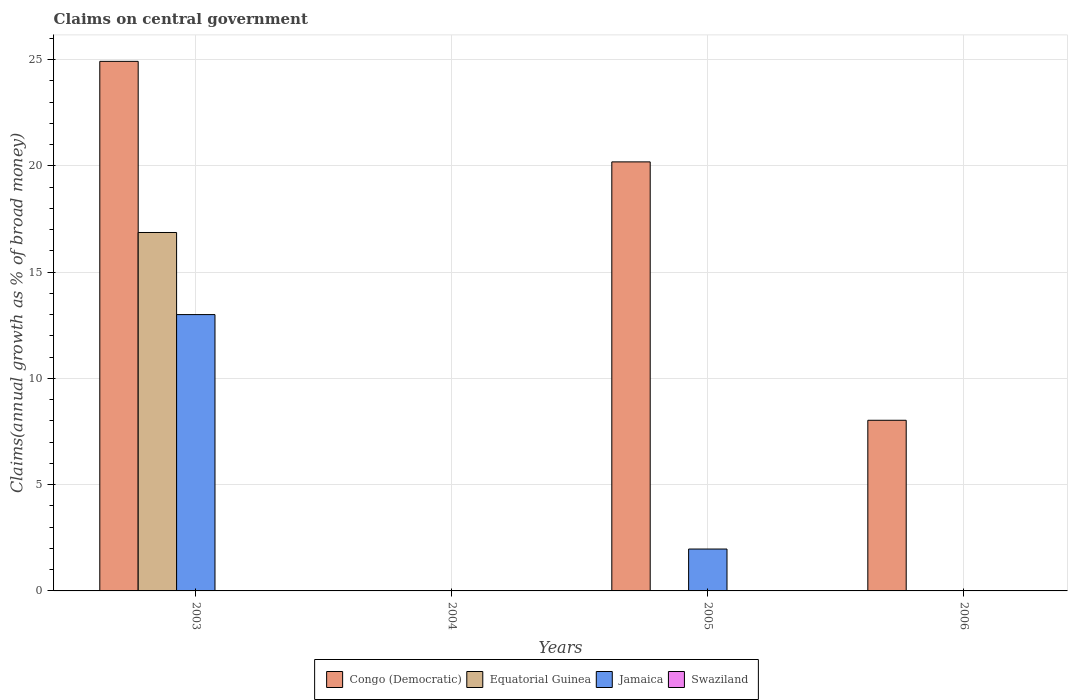Are the number of bars per tick equal to the number of legend labels?
Your answer should be very brief. No. Are the number of bars on each tick of the X-axis equal?
Your response must be concise. No. How many bars are there on the 2nd tick from the left?
Ensure brevity in your answer.  0. How many bars are there on the 3rd tick from the right?
Give a very brief answer. 0. What is the label of the 4th group of bars from the left?
Make the answer very short. 2006. Across all years, what is the maximum percentage of broad money claimed on centeral government in Equatorial Guinea?
Provide a succinct answer. 16.86. What is the total percentage of broad money claimed on centeral government in Swaziland in the graph?
Provide a succinct answer. 0. What is the difference between the percentage of broad money claimed on centeral government in Congo (Democratic) in 2003 and that in 2005?
Keep it short and to the point. 4.73. What is the difference between the percentage of broad money claimed on centeral government in Congo (Democratic) in 2005 and the percentage of broad money claimed on centeral government in Jamaica in 2006?
Your answer should be compact. 20.18. What is the average percentage of broad money claimed on centeral government in Congo (Democratic) per year?
Provide a succinct answer. 13.28. In the year 2005, what is the difference between the percentage of broad money claimed on centeral government in Congo (Democratic) and percentage of broad money claimed on centeral government in Jamaica?
Your answer should be compact. 18.21. In how many years, is the percentage of broad money claimed on centeral government in Swaziland greater than 18 %?
Give a very brief answer. 0. What is the difference between the highest and the second highest percentage of broad money claimed on centeral government in Congo (Democratic)?
Provide a short and direct response. 4.73. What is the difference between the highest and the lowest percentage of broad money claimed on centeral government in Jamaica?
Your response must be concise. 13. In how many years, is the percentage of broad money claimed on centeral government in Jamaica greater than the average percentage of broad money claimed on centeral government in Jamaica taken over all years?
Give a very brief answer. 1. Is it the case that in every year, the sum of the percentage of broad money claimed on centeral government in Swaziland and percentage of broad money claimed on centeral government in Congo (Democratic) is greater than the sum of percentage of broad money claimed on centeral government in Jamaica and percentage of broad money claimed on centeral government in Equatorial Guinea?
Offer a very short reply. No. How many bars are there?
Provide a short and direct response. 6. What is the difference between two consecutive major ticks on the Y-axis?
Your answer should be very brief. 5. Are the values on the major ticks of Y-axis written in scientific E-notation?
Your answer should be very brief. No. Does the graph contain any zero values?
Keep it short and to the point. Yes. Where does the legend appear in the graph?
Your answer should be very brief. Bottom center. How many legend labels are there?
Provide a short and direct response. 4. What is the title of the graph?
Give a very brief answer. Claims on central government. Does "South Sudan" appear as one of the legend labels in the graph?
Make the answer very short. No. What is the label or title of the X-axis?
Ensure brevity in your answer.  Years. What is the label or title of the Y-axis?
Offer a very short reply. Claims(annual growth as % of broad money). What is the Claims(annual growth as % of broad money) of Congo (Democratic) in 2003?
Provide a succinct answer. 24.91. What is the Claims(annual growth as % of broad money) in Equatorial Guinea in 2003?
Provide a short and direct response. 16.86. What is the Claims(annual growth as % of broad money) of Jamaica in 2003?
Make the answer very short. 13. What is the Claims(annual growth as % of broad money) in Swaziland in 2003?
Your answer should be compact. 0. What is the Claims(annual growth as % of broad money) in Congo (Democratic) in 2004?
Offer a terse response. 0. What is the Claims(annual growth as % of broad money) of Jamaica in 2004?
Keep it short and to the point. 0. What is the Claims(annual growth as % of broad money) in Congo (Democratic) in 2005?
Ensure brevity in your answer.  20.18. What is the Claims(annual growth as % of broad money) of Jamaica in 2005?
Your response must be concise. 1.97. What is the Claims(annual growth as % of broad money) of Swaziland in 2005?
Offer a very short reply. 0. What is the Claims(annual growth as % of broad money) in Congo (Democratic) in 2006?
Offer a very short reply. 8.03. Across all years, what is the maximum Claims(annual growth as % of broad money) of Congo (Democratic)?
Provide a succinct answer. 24.91. Across all years, what is the maximum Claims(annual growth as % of broad money) of Equatorial Guinea?
Offer a very short reply. 16.86. Across all years, what is the maximum Claims(annual growth as % of broad money) in Jamaica?
Your answer should be very brief. 13. Across all years, what is the minimum Claims(annual growth as % of broad money) of Equatorial Guinea?
Make the answer very short. 0. What is the total Claims(annual growth as % of broad money) of Congo (Democratic) in the graph?
Make the answer very short. 53.13. What is the total Claims(annual growth as % of broad money) of Equatorial Guinea in the graph?
Keep it short and to the point. 16.86. What is the total Claims(annual growth as % of broad money) of Jamaica in the graph?
Keep it short and to the point. 14.97. What is the total Claims(annual growth as % of broad money) of Swaziland in the graph?
Keep it short and to the point. 0. What is the difference between the Claims(annual growth as % of broad money) of Congo (Democratic) in 2003 and that in 2005?
Offer a terse response. 4.73. What is the difference between the Claims(annual growth as % of broad money) of Jamaica in 2003 and that in 2005?
Offer a terse response. 11.03. What is the difference between the Claims(annual growth as % of broad money) in Congo (Democratic) in 2003 and that in 2006?
Offer a terse response. 16.89. What is the difference between the Claims(annual growth as % of broad money) of Congo (Democratic) in 2005 and that in 2006?
Your answer should be very brief. 12.16. What is the difference between the Claims(annual growth as % of broad money) in Congo (Democratic) in 2003 and the Claims(annual growth as % of broad money) in Jamaica in 2005?
Your answer should be compact. 22.94. What is the difference between the Claims(annual growth as % of broad money) in Equatorial Guinea in 2003 and the Claims(annual growth as % of broad money) in Jamaica in 2005?
Provide a short and direct response. 14.89. What is the average Claims(annual growth as % of broad money) in Congo (Democratic) per year?
Make the answer very short. 13.28. What is the average Claims(annual growth as % of broad money) in Equatorial Guinea per year?
Offer a terse response. 4.22. What is the average Claims(annual growth as % of broad money) of Jamaica per year?
Provide a succinct answer. 3.74. In the year 2003, what is the difference between the Claims(annual growth as % of broad money) of Congo (Democratic) and Claims(annual growth as % of broad money) of Equatorial Guinea?
Make the answer very short. 8.05. In the year 2003, what is the difference between the Claims(annual growth as % of broad money) in Congo (Democratic) and Claims(annual growth as % of broad money) in Jamaica?
Provide a succinct answer. 11.91. In the year 2003, what is the difference between the Claims(annual growth as % of broad money) of Equatorial Guinea and Claims(annual growth as % of broad money) of Jamaica?
Your answer should be compact. 3.86. In the year 2005, what is the difference between the Claims(annual growth as % of broad money) of Congo (Democratic) and Claims(annual growth as % of broad money) of Jamaica?
Your response must be concise. 18.21. What is the ratio of the Claims(annual growth as % of broad money) of Congo (Democratic) in 2003 to that in 2005?
Your response must be concise. 1.23. What is the ratio of the Claims(annual growth as % of broad money) in Jamaica in 2003 to that in 2005?
Offer a terse response. 6.6. What is the ratio of the Claims(annual growth as % of broad money) of Congo (Democratic) in 2003 to that in 2006?
Your answer should be very brief. 3.1. What is the ratio of the Claims(annual growth as % of broad money) of Congo (Democratic) in 2005 to that in 2006?
Provide a succinct answer. 2.51. What is the difference between the highest and the second highest Claims(annual growth as % of broad money) in Congo (Democratic)?
Provide a succinct answer. 4.73. What is the difference between the highest and the lowest Claims(annual growth as % of broad money) in Congo (Democratic)?
Give a very brief answer. 24.91. What is the difference between the highest and the lowest Claims(annual growth as % of broad money) of Equatorial Guinea?
Keep it short and to the point. 16.86. What is the difference between the highest and the lowest Claims(annual growth as % of broad money) in Jamaica?
Your answer should be very brief. 13. 